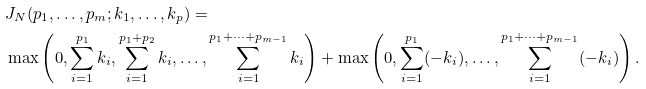<formula> <loc_0><loc_0><loc_500><loc_500>& J _ { N } ( p _ { 1 } , \dots , p _ { m } ; k _ { 1 } , \dots , k _ { p } ) = \\ & \max \left ( 0 , \sum _ { i = 1 } ^ { p _ { 1 } } k _ { i } , \sum _ { i = 1 } ^ { p _ { 1 } + p _ { 2 } } k _ { i } , \dots , \sum _ { i = 1 } ^ { p _ { 1 } + \dots + p _ { m - 1 } } k _ { i } \right ) + \max \left ( 0 , \sum _ { i = 1 } ^ { p _ { 1 } } ( - k _ { i } ) , \dots , \sum _ { i = 1 } ^ { p _ { 1 } + \dots + p _ { m - 1 } } ( - k _ { i } ) \right ) .</formula> 